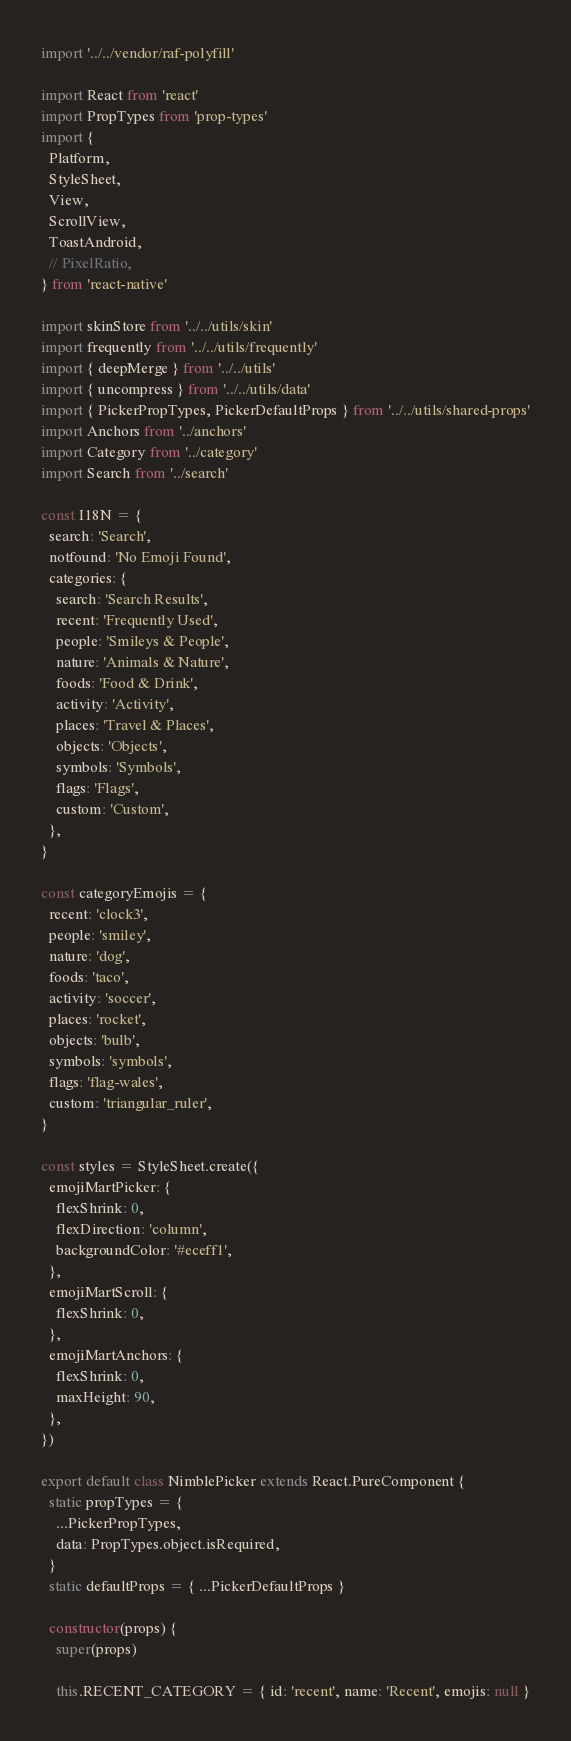Convert code to text. <code><loc_0><loc_0><loc_500><loc_500><_JavaScript_>import '../../vendor/raf-polyfill'

import React from 'react'
import PropTypes from 'prop-types'
import {
  Platform,
  StyleSheet,
  View,
  ScrollView,
  ToastAndroid,
  // PixelRatio,
} from 'react-native'

import skinStore from '../../utils/skin'
import frequently from '../../utils/frequently'
import { deepMerge } from '../../utils'
import { uncompress } from '../../utils/data'
import { PickerPropTypes, PickerDefaultProps } from '../../utils/shared-props'
import Anchors from '../anchors'
import Category from '../category'
import Search from '../search'

const I18N = {
  search: 'Search',
  notfound: 'No Emoji Found',
  categories: {
    search: 'Search Results',
    recent: 'Frequently Used',
    people: 'Smileys & People',
    nature: 'Animals & Nature',
    foods: 'Food & Drink',
    activity: 'Activity',
    places: 'Travel & Places',
    objects: 'Objects',
    symbols: 'Symbols',
    flags: 'Flags',
    custom: 'Custom',
  },
}

const categoryEmojis = {
  recent: 'clock3',
  people: 'smiley',
  nature: 'dog',
  foods: 'taco',
  activity: 'soccer',
  places: 'rocket',
  objects: 'bulb',
  symbols: 'symbols',
  flags: 'flag-wales',
  custom: 'triangular_ruler',
}

const styles = StyleSheet.create({
  emojiMartPicker: {
    flexShrink: 0,
    flexDirection: 'column',
    backgroundColor: '#eceff1',
  },
  emojiMartScroll: {
    flexShrink: 0,
  },
  emojiMartAnchors: {
    flexShrink: 0,
    maxHeight: 90,
  },
})

export default class NimblePicker extends React.PureComponent {
  static propTypes = {
    ...PickerPropTypes,
    data: PropTypes.object.isRequired,
  }
  static defaultProps = { ...PickerDefaultProps }

  constructor(props) {
    super(props)

    this.RECENT_CATEGORY = { id: 'recent', name: 'Recent', emojis: null }</code> 